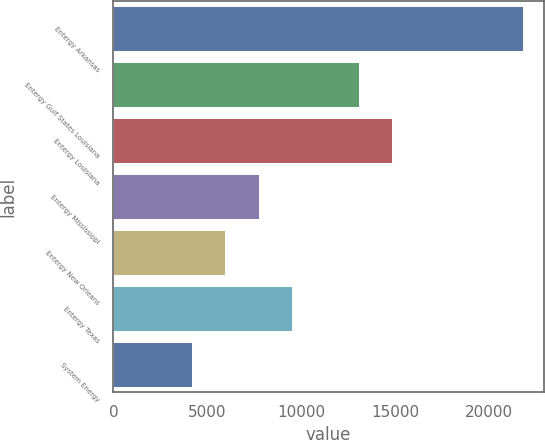Convert chart to OTSL. <chart><loc_0><loc_0><loc_500><loc_500><bar_chart><fcel>Entergy Arkansas<fcel>Entergy Gulf States Louisiana<fcel>Entergy Louisiana<fcel>Entergy Mississippi<fcel>Entergy New Orleans<fcel>Entergy Texas<fcel>System Energy<nl><fcel>21820<fcel>13069<fcel>14830.1<fcel>7731.2<fcel>5970.1<fcel>9492.3<fcel>4209<nl></chart> 